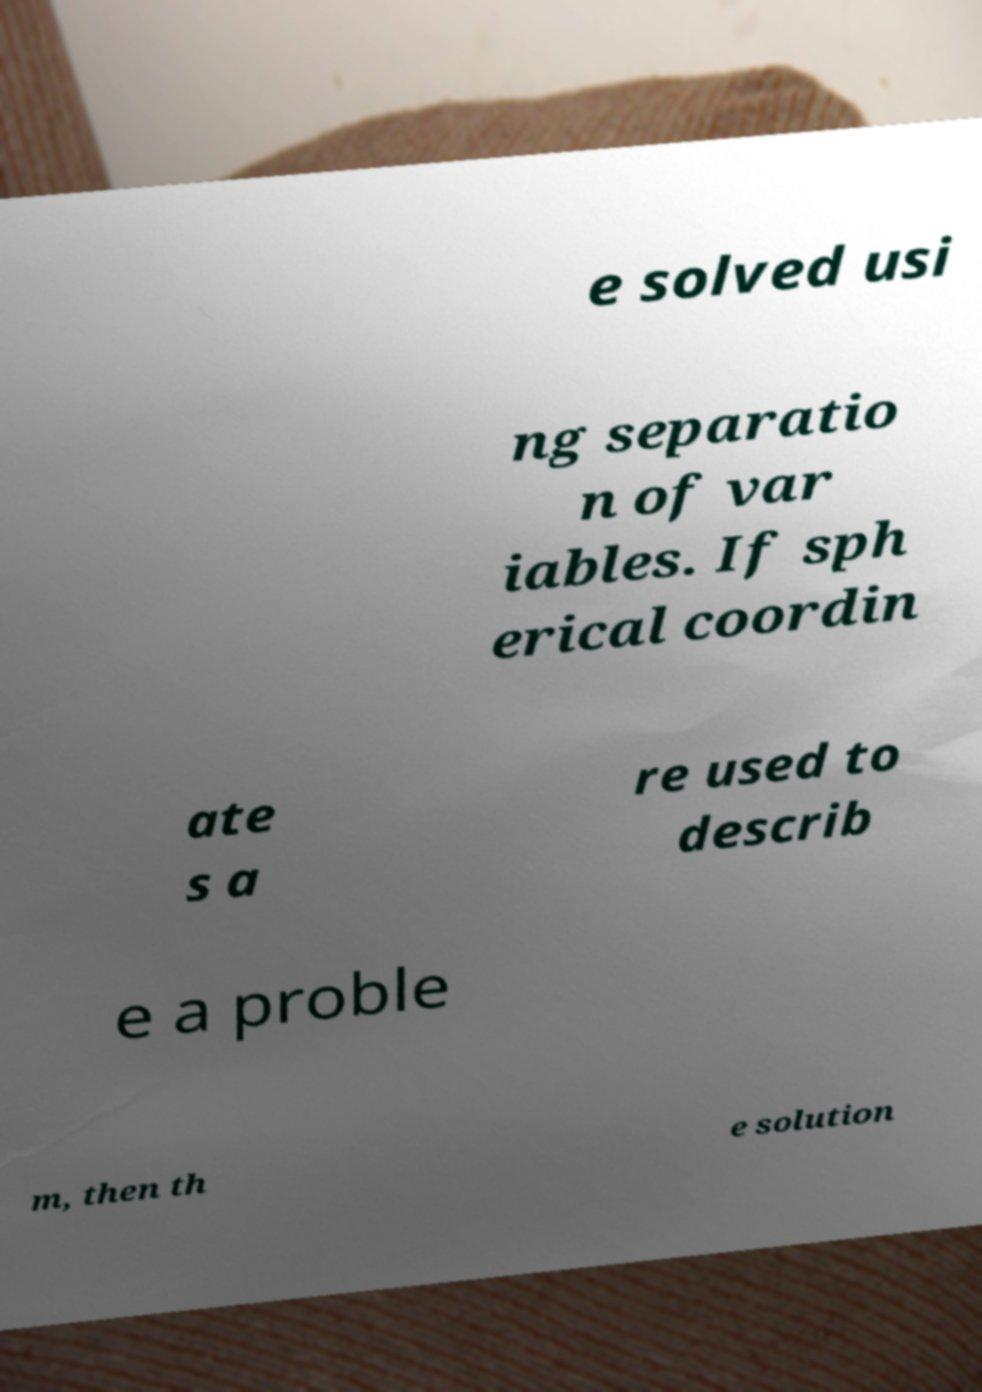For documentation purposes, I need the text within this image transcribed. Could you provide that? e solved usi ng separatio n of var iables. If sph erical coordin ate s a re used to describ e a proble m, then th e solution 